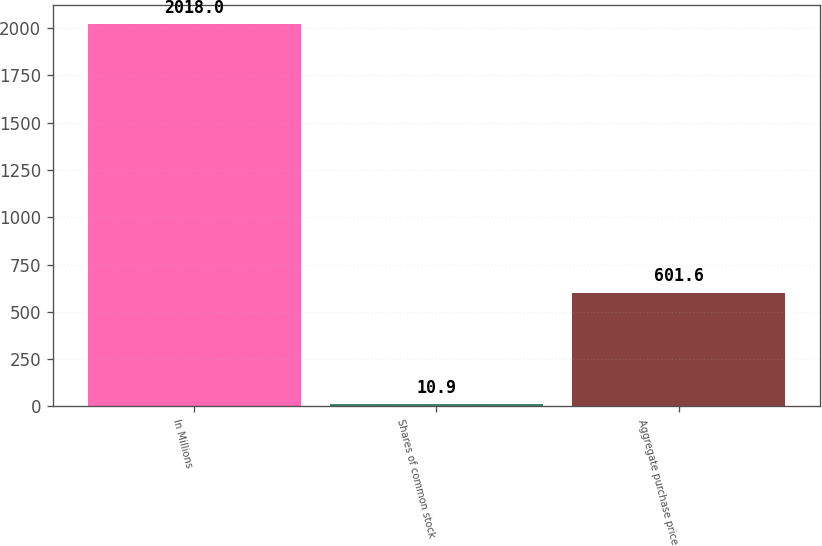Convert chart. <chart><loc_0><loc_0><loc_500><loc_500><bar_chart><fcel>In Millions<fcel>Shares of common stock<fcel>Aggregate purchase price<nl><fcel>2018<fcel>10.9<fcel>601.6<nl></chart> 